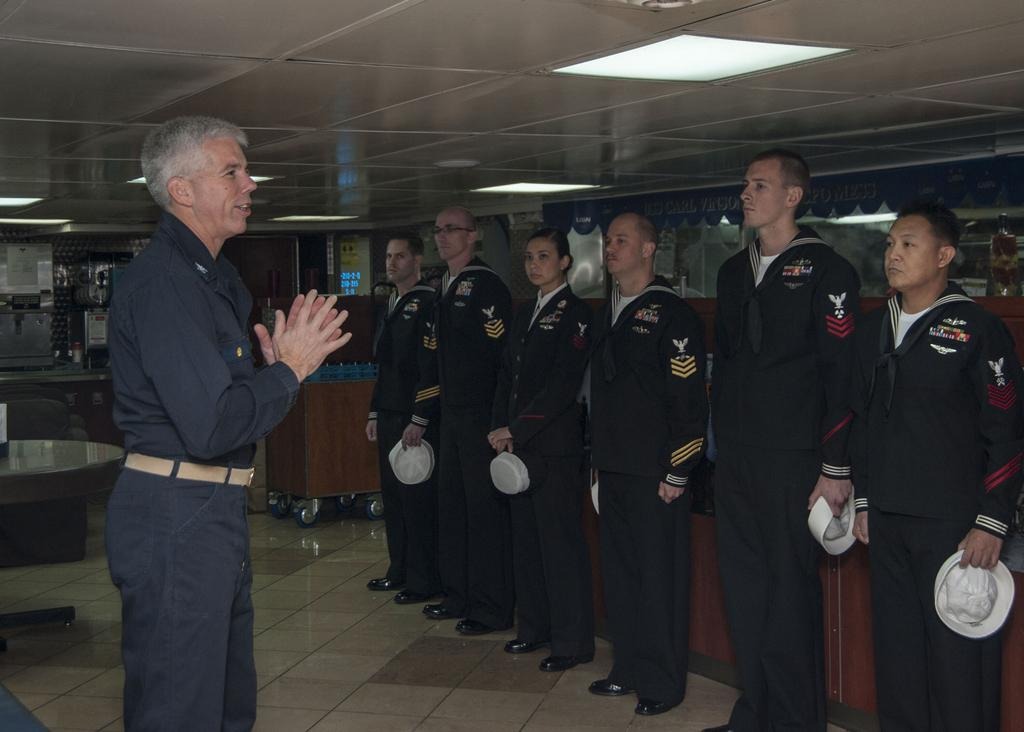What can be seen on the right side of the image? There are people standing in series on the right side of the image. What is the position of the man in the image? The man is standing on the left side of the image. What type of milk is being served to the people in the image? There is no milk present in the image. Who is the owner of the people standing in series in the image? The image does not provide information about the ownership or relationship between the people. 